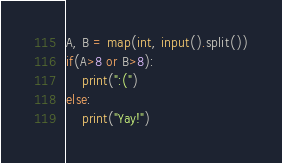<code> <loc_0><loc_0><loc_500><loc_500><_Python_>A, B = map(int, input().split())
if(A>8 or B>8):
    print(":(")
else:
    print("Yay!")</code> 